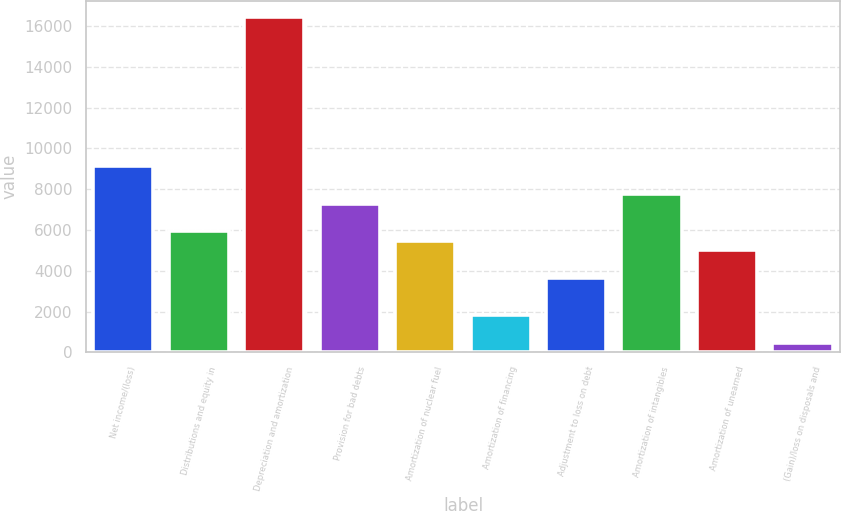Convert chart to OTSL. <chart><loc_0><loc_0><loc_500><loc_500><bar_chart><fcel>Net income/(loss)<fcel>Distributions and equity in<fcel>Depreciation and amortization<fcel>Provision for bad debts<fcel>Amortization of nuclear fuel<fcel>Amortization of financing<fcel>Adjustment to loss on debt<fcel>Amortization of intangibles<fcel>Amortization of unearned<fcel>(Gain)/loss on disposals and<nl><fcel>9124<fcel>5931.3<fcel>16421.6<fcel>7299.6<fcel>5475.2<fcel>1826.4<fcel>3650.8<fcel>7755.7<fcel>5019.1<fcel>458.1<nl></chart> 